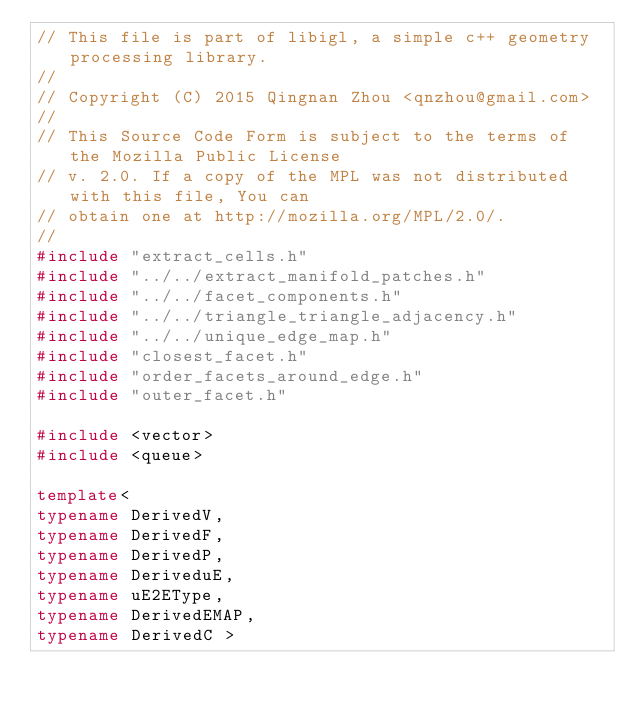Convert code to text. <code><loc_0><loc_0><loc_500><loc_500><_C++_>// This file is part of libigl, a simple c++ geometry processing library.
// 
// Copyright (C) 2015 Qingnan Zhou <qnzhou@gmail.com>
// 
// This Source Code Form is subject to the terms of the Mozilla Public License 
// v. 2.0. If a copy of the MPL was not distributed with this file, You can 
// obtain one at http://mozilla.org/MPL/2.0/.
//
#include "extract_cells.h"
#include "../../extract_manifold_patches.h"
#include "../../facet_components.h"
#include "../../triangle_triangle_adjacency.h"
#include "../../unique_edge_map.h"
#include "closest_facet.h"
#include "order_facets_around_edge.h"
#include "outer_facet.h"

#include <vector>
#include <queue>

template<
typename DerivedV,
typename DerivedF,
typename DerivedP,
typename DeriveduE,
typename uE2EType,
typename DerivedEMAP,
typename DerivedC ></code> 